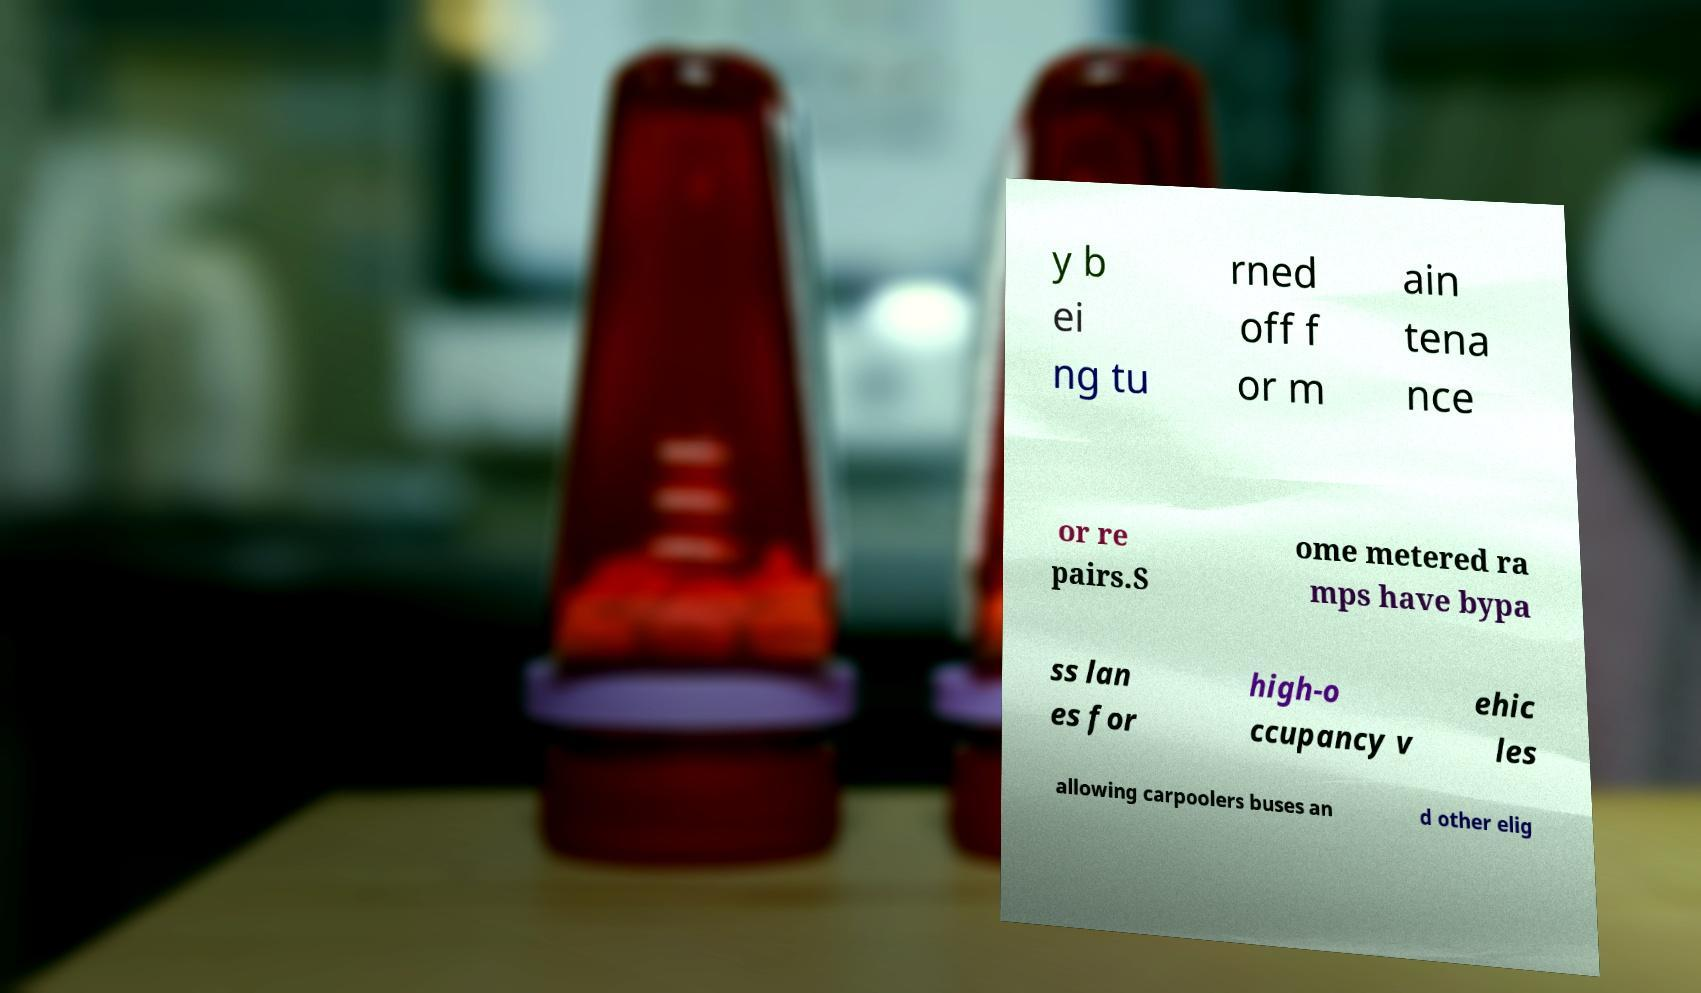For documentation purposes, I need the text within this image transcribed. Could you provide that? y b ei ng tu rned off f or m ain tena nce or re pairs.S ome metered ra mps have bypa ss lan es for high-o ccupancy v ehic les allowing carpoolers buses an d other elig 